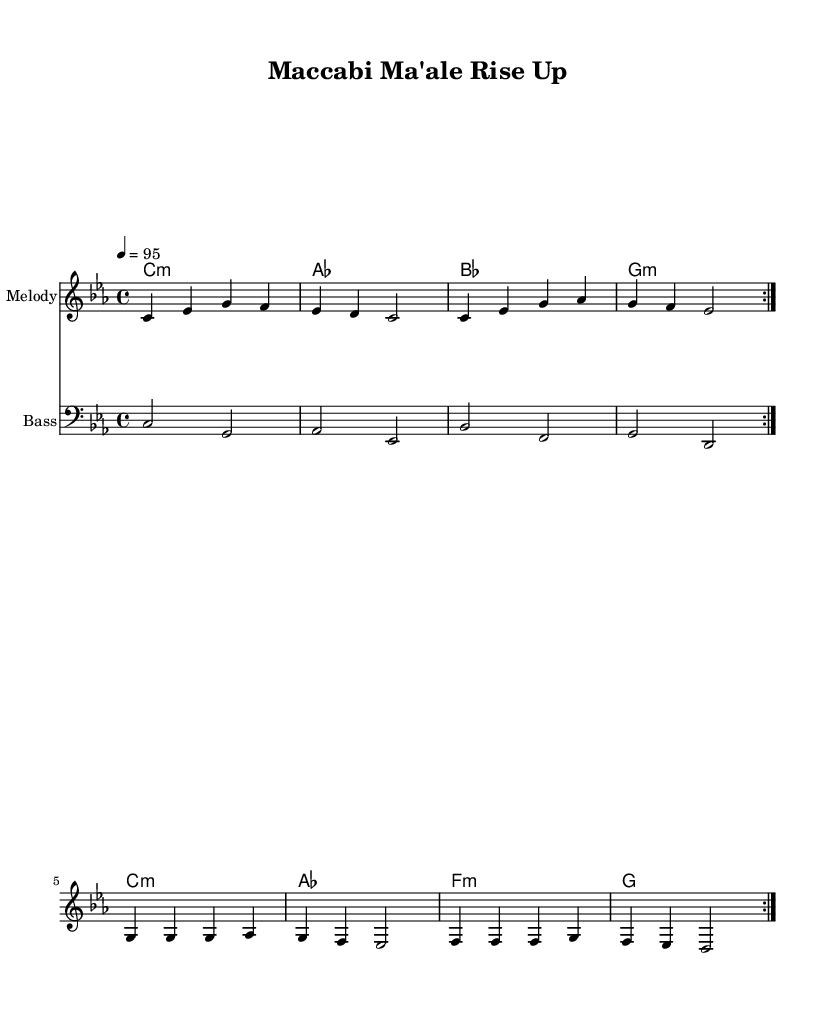What is the key signature of this music? The key signature is C minor, which has three flats (B♭, E♭, A♭). This is indicated in the global section of the sheet music.
Answer: C minor What is the time signature of this piece? The time signature is 4/4, which means there are four beats in each measure and the quarter note gets one beat. This can be seen in the global section of the score.
Answer: 4/4 What is the tempo marking for this piece? The tempo marking is set at 95 beats per minute, which denotes the speed at which the piece should be played. This is specified in the global section of the sheet music.
Answer: 95 How many times is the chorus repeated? The chorus is repeated two times, as indicated by the "repeat volta 2" marking in the melody section. This tells us the structure includes a repeated section.
Answer: 2 What type of music genre does this piece represent? The piece represents the Rap genre, which is characterized by rhythmic lyrics and a strong vocal delivery. This is evident from the lyrical content and the structure intended for motivational settings.
Answer: Rap What is the first lyric line of the verse? The first lyric line of the verse is "Mac -- ca -- bi Ma' -- ale, rise up and shine," which can be found in the lyrics section of the score. This sets the motivational tone of the piece.
Answer: Mac -- ca -- bi Ma' -- ale, rise up and shine What instruments are used in this score? The instruments used in this score include a melody staff and a bass staff, as indicated in the score section where different parts are laid out separately for performance.
Answer: Melody, Bass 